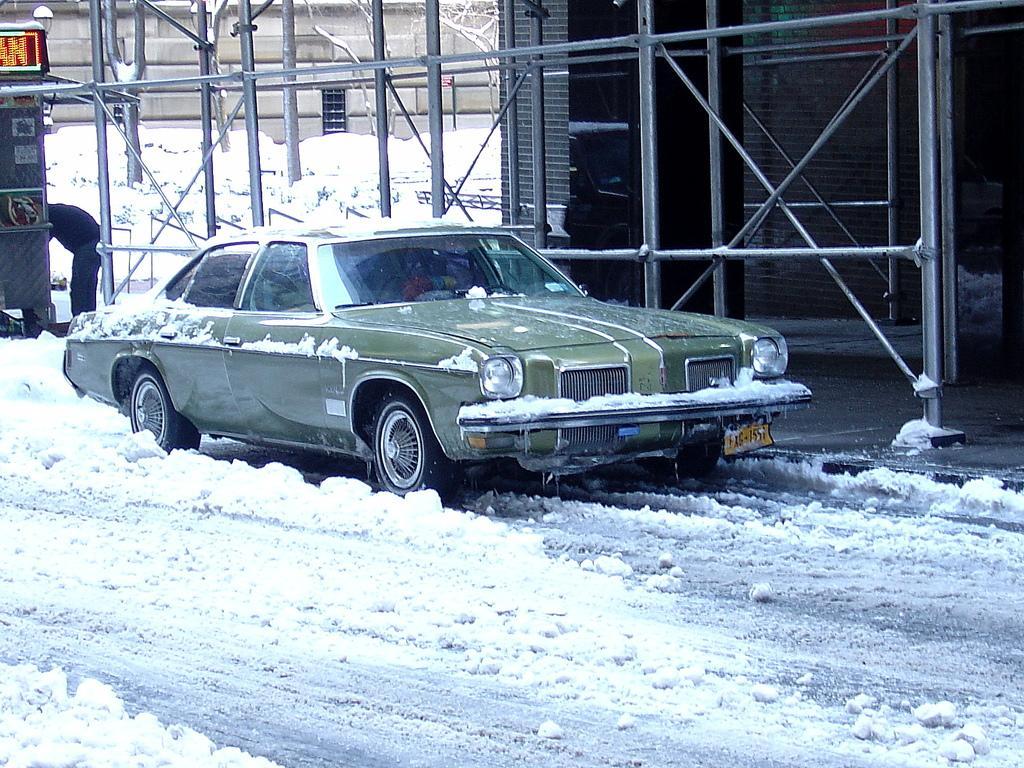In one or two sentences, can you explain what this image depicts? In this picture we can see snow and a car on the road. In the background we can see a person, poles, walls, trees and some objects. 